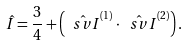<formula> <loc_0><loc_0><loc_500><loc_500>\hat { I } = \frac { 3 } { 4 } + \left ( \hat { \ s v { I } } ^ { ( 1 ) } \cdot \hat { \ s v { I } } ^ { ( 2 ) } \right ) .</formula> 